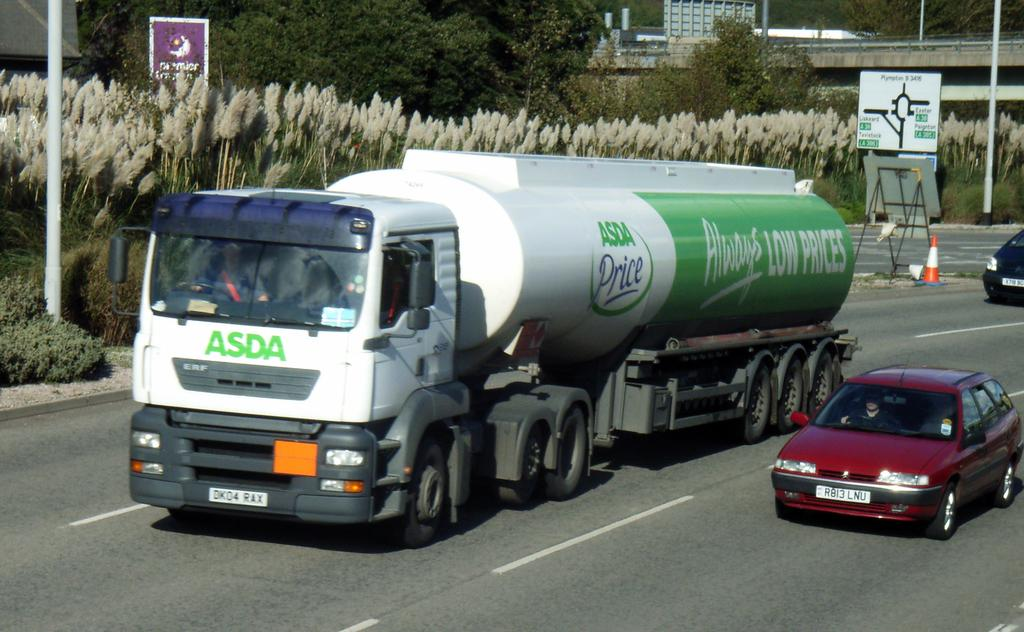What can be seen on the road in the image? There are vehicles on the road in the image. What type of vegetation is present in the image? There are plants and trees in the image. What is located in the middle of the road in the image? There is a caution sign in the middle of the road in the image. What type of reaction can be seen in the image? There is no reaction visible in the image; it is a still photograph. What type of station is depicted in the image? There is no station present in the image. 